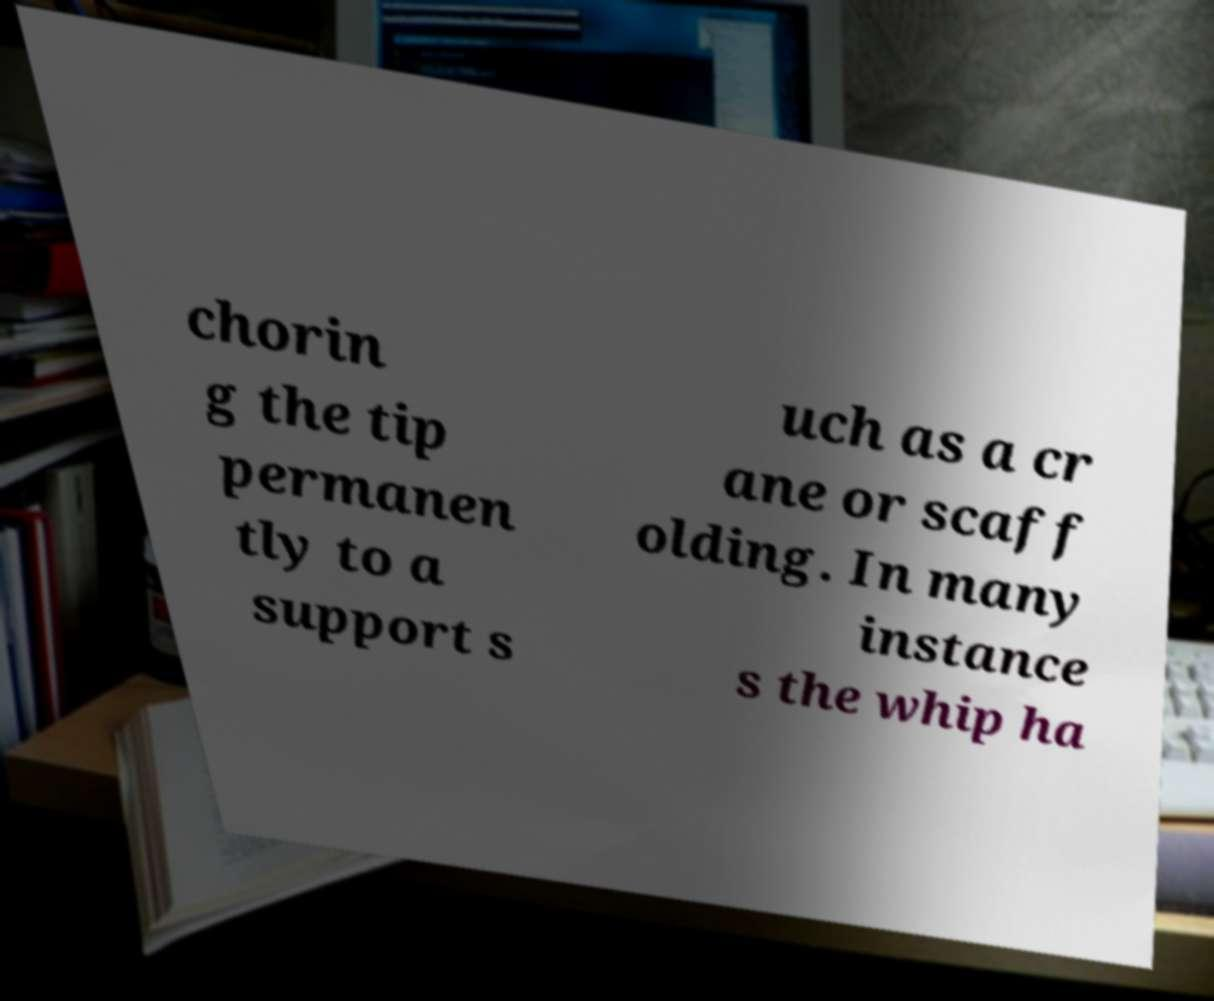Please identify and transcribe the text found in this image. chorin g the tip permanen tly to a support s uch as a cr ane or scaff olding. In many instance s the whip ha 